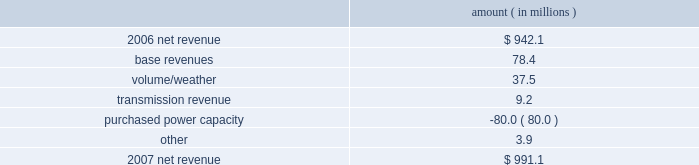Entergy louisiana , llc management's financial discussion and analysis 2007 compared to 2006 net revenue consists of operating revenues net of : 1 ) fuel , fuel-related expenses , and gas purchased for resale , 2 ) purchased power expenses , and 3 ) other regulatory charges ( credits ) .
Following is an analysis of the change in net revenue comparing 2007 to 2006 .
Amount ( in millions ) .
The base revenues variance is primarily due to increases effective september 2006 for the 2005 formula rate plan filing to recover lpsc-approved incremental deferred and ongoing capacity costs .
See "state and local rate regulation" below and note 2 to the financial statements for a discussion of the formula rate plan filing .
The volume/weather variance is due to increased electricity usage , including electricity sales during the unbilled service period .
Billed retail electricity usage increased a total of 666 gwh in all sectors compared to 2006 .
See "critical accounting estimates" below and note 1 to the financial statements for further discussion of the accounting for unbilled revenues .
The transmission revenue variance is primarily due to higher rates .
The purchased power capacity variance is primarily due to higher purchased power capacity charges and the amortization of capacity charges effective september 2006 as a result of the formula rate plan filing in may 2006 .
A portion of the purchased power capacity costs is offset in base revenues due to a base rate increase implemented to recover incremental deferred and ongoing purchased power capacity charges , as mentioned above .
See "state and local rate regulation" below and note 2 to the financial statements for a discussion of the formula rate plan filing .
Gross operating revenues , fuel , purchased power expenses , and other regulatory charges ( credits ) gross operating revenues increased primarily due to : an increase of $ 143.1 million in fuel cost recovery revenues due to higher fuel rates and usage ; an increase of $ 78.4 million in base revenues , as discussed above ; and an increase of $ 37.5 million related to volume/weather , as discussed above .
Fuel and purchased power expenses increased primarily due to an increase in net area demand and an increase in deferred fuel expense as a result of higher fuel rates , as discussed above .
Other regulatory credits decreased primarily due to the deferral of capacity charges in 2006 in addition to the amortization of these capacity charges in 2007 as a result of the may 2006 formula rate plan filing ( for the 2005 test year ) with the lpsc to recover such costs through base rates effective september 2006 .
See note 2 to the financial statements for a discussion of the formula rate plan and storm cost recovery filings with the lpsc. .
What is the percent change in net revenue between 2006 and 2007? 
Computations: ((991.1 - 942.1) / 942.1)
Answer: 0.05201. 